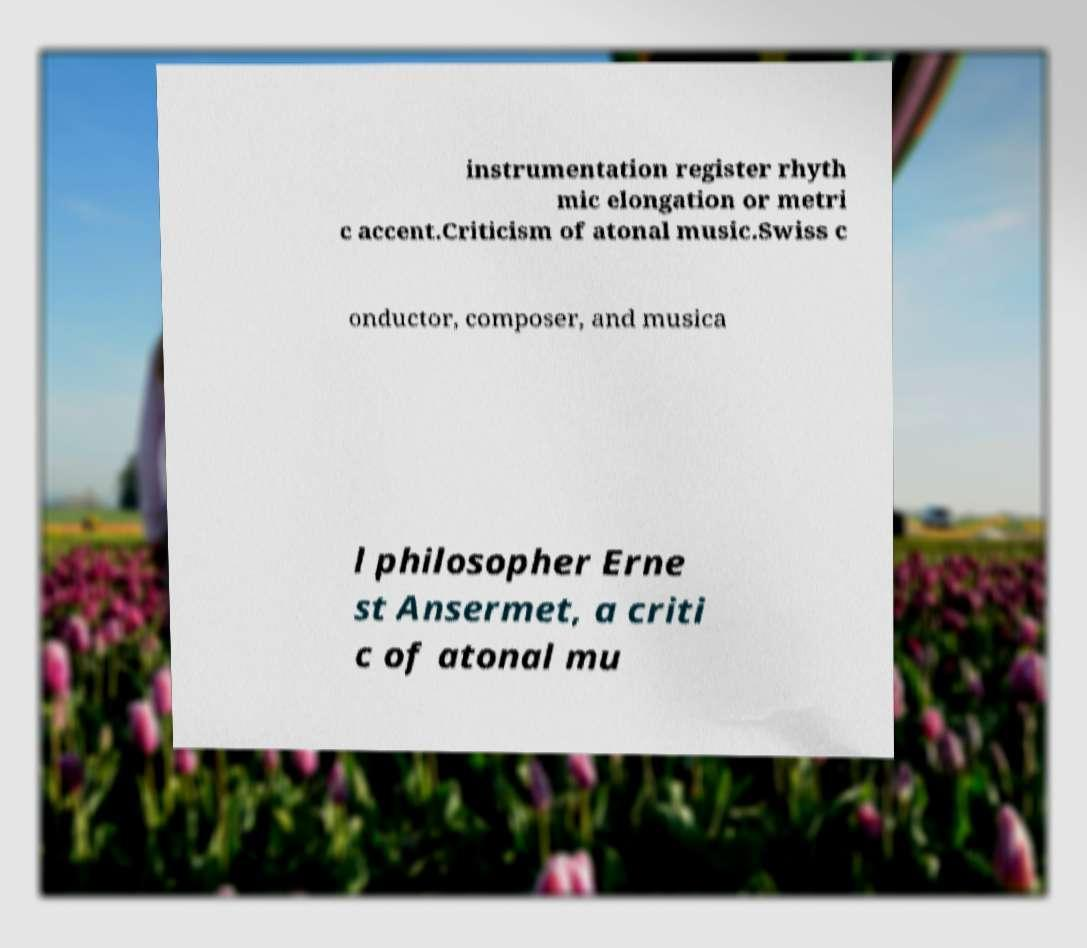Could you extract and type out the text from this image? instrumentation register rhyth mic elongation or metri c accent.Criticism of atonal music.Swiss c onductor, composer, and musica l philosopher Erne st Ansermet, a criti c of atonal mu 